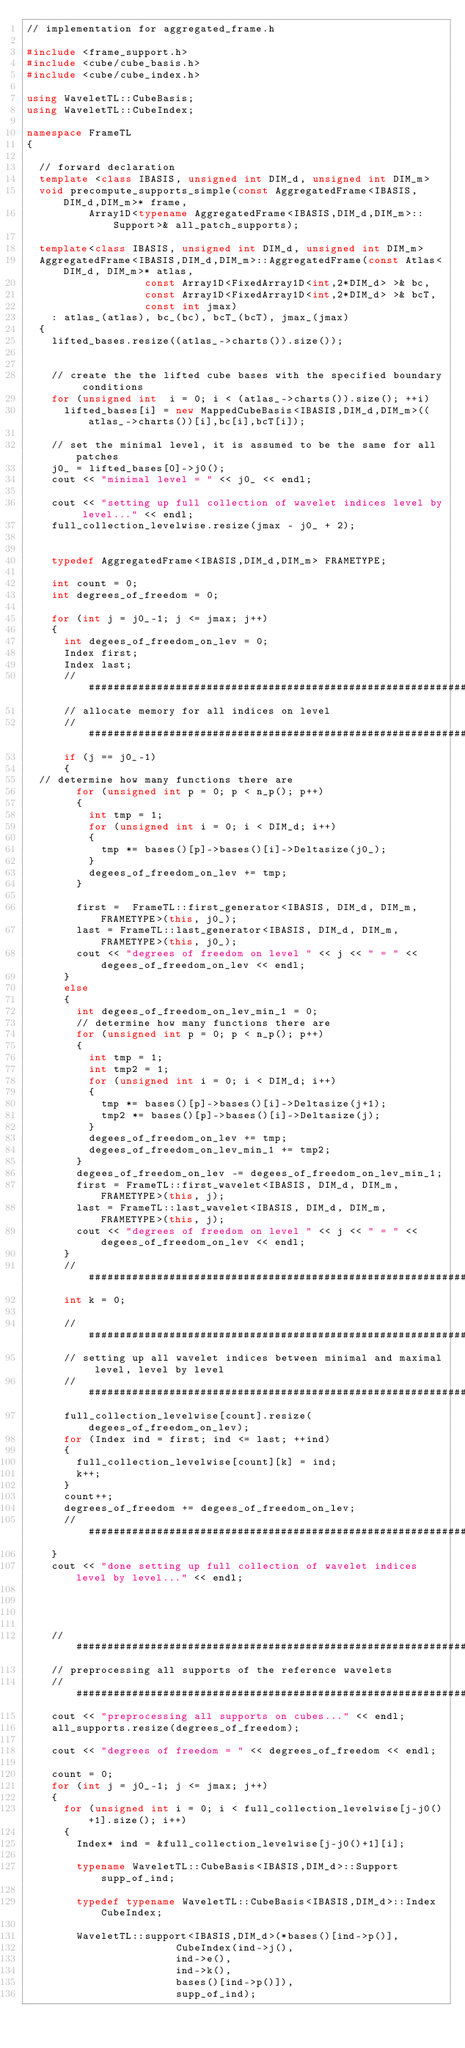Convert code to text. <code><loc_0><loc_0><loc_500><loc_500><_C++_>// implementation for aggregated_frame.h

#include <frame_support.h>
#include <cube/cube_basis.h>
#include <cube/cube_index.h>

using WaveletTL::CubeBasis;
using WaveletTL::CubeIndex;

namespace FrameTL
{

  // forward declaration
  template <class IBASIS, unsigned int DIM_d, unsigned int DIM_m>
  void precompute_supports_simple(const AggregatedFrame<IBASIS,DIM_d,DIM_m>* frame,
				  Array1D<typename AggregatedFrame<IBASIS,DIM_d,DIM_m>::Support>& all_patch_supports);

  template<class IBASIS, unsigned int DIM_d, unsigned int DIM_m>
  AggregatedFrame<IBASIS,DIM_d,DIM_m>::AggregatedFrame(const Atlas<DIM_d, DIM_m>* atlas,
						       const Array1D<FixedArray1D<int,2*DIM_d> >& bc,
						       const Array1D<FixedArray1D<int,2*DIM_d> >& bcT,
						       const int jmax)
    : atlas_(atlas), bc_(bc), bcT_(bcT), jmax_(jmax)
  {
    lifted_bases.resize((atlas_->charts()).size());


    // create the the lifted cube bases with the specified boundary conditions
    for (unsigned int  i = 0; i < (atlas_->charts()).size(); ++i)
      lifted_bases[i] = new MappedCubeBasis<IBASIS,DIM_d,DIM_m>((atlas_->charts())[i],bc[i],bcT[i]);

    // set the minimal level, it is assumed to be the same for all patches
    j0_ = lifted_bases[0]->j0();
    cout << "minimal level = " << j0_ << endl;

    cout << "setting up full collection of wavelet indices level by level..." << endl;
    full_collection_levelwise.resize(jmax - j0_ + 2);


    typedef AggregatedFrame<IBASIS,DIM_d,DIM_m> FRAMETYPE;

    int count = 0;
    int degrees_of_freedom = 0;

    for (int j = j0_-1; j <= jmax; j++)
    {
      int degees_of_freedom_on_lev = 0;
      Index first;
      Index last;
      // #####################################################################################
      // allocate memory for all indices on level
      // #####################################################################################
      if (j == j0_-1)
      {
	// determine how many functions there are
        for (unsigned int p = 0; p < n_p(); p++)
        {
          int tmp = 1;
          for (unsigned int i = 0; i < DIM_d; i++)
          {
            tmp *= bases()[p]->bases()[i]->Deltasize(j0_);
          }
          degees_of_freedom_on_lev += tmp;
        }

        first =  FrameTL::first_generator<IBASIS, DIM_d, DIM_m, FRAMETYPE>(this, j0_);
        last = FrameTL::last_generator<IBASIS, DIM_d, DIM_m, FRAMETYPE>(this, j0_);
        cout << "degrees of freedom on level " << j << " = " <<  degees_of_freedom_on_lev << endl;
      }
      else
      {
        int degees_of_freedom_on_lev_min_1 = 0;
        // determine how many functions there are
        for (unsigned int p = 0; p < n_p(); p++)
        {
          int tmp = 1;
          int tmp2 = 1;
          for (unsigned int i = 0; i < DIM_d; i++)
          {
            tmp *= bases()[p]->bases()[i]->Deltasize(j+1);
            tmp2 *= bases()[p]->bases()[i]->Deltasize(j);
          }
          degees_of_freedom_on_lev += tmp;
          degees_of_freedom_on_lev_min_1 += tmp2;
        }
        degees_of_freedom_on_lev -= degees_of_freedom_on_lev_min_1;
        first = FrameTL::first_wavelet<IBASIS, DIM_d, DIM_m, FRAMETYPE>(this, j);
        last = FrameTL::last_wavelet<IBASIS, DIM_d, DIM_m, FRAMETYPE>(this, j);
        cout << "degrees of freedom on level " << j << " = " << degees_of_freedom_on_lev << endl;
      }
      // #####################################################################################
      int k = 0;

      // #####################################################################################
      // setting up all wavelet indices between minimal and maximal level, level by level
      // #####################################################################################
      full_collection_levelwise[count].resize(degees_of_freedom_on_lev);
      for (Index ind = first; ind <= last; ++ind)
      {
        full_collection_levelwise[count][k] = ind;
        k++;
      }
      count++;
      degrees_of_freedom += degees_of_freedom_on_lev;
      // #####################################################################################
    }
    cout << "done setting up full collection of wavelet indices level by level..." << endl;




    // #####################################################################################
    // preprocessing all supports of the reference wavelets
    // #####################################################################################
    cout << "preprocessing all supports on cubes..." << endl;
    all_supports.resize(degrees_of_freedom);

    cout << "degrees of freedom = " << degrees_of_freedom << endl;

    count = 0;
    for (int j = j0_-1; j <= jmax; j++)
    {
      for (unsigned int i = 0; i < full_collection_levelwise[j-j0()+1].size(); i++)
      {
        Index* ind = &full_collection_levelwise[j-j0()+1][i];

        typename WaveletTL::CubeBasis<IBASIS,DIM_d>::Support supp_of_ind;

        typedef typename WaveletTL::CubeBasis<IBASIS,DIM_d>::Index CubeIndex;

        WaveletTL::support<IBASIS,DIM_d>(*bases()[ind->p()],
                        CubeIndex(ind->j(),
                        ind->e(),
                        ind->k(),
                        bases()[ind->p()]),
                        supp_of_ind);
</code> 